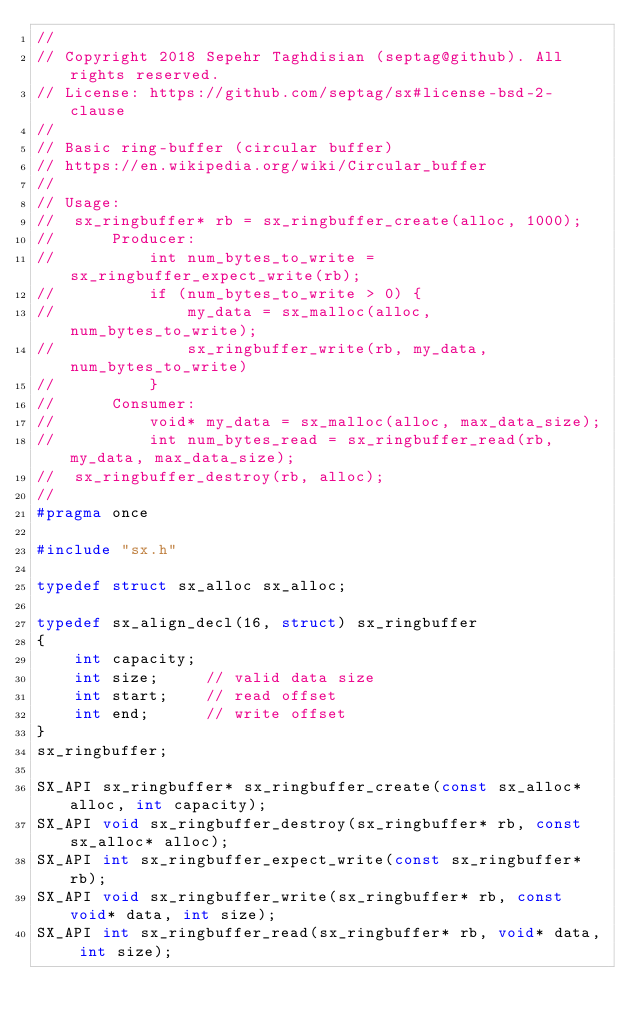Convert code to text. <code><loc_0><loc_0><loc_500><loc_500><_C_>//
// Copyright 2018 Sepehr Taghdisian (septag@github). All rights reserved.
// License: https://github.com/septag/sx#license-bsd-2-clause
//
// Basic ring-buffer (circular buffer)
// https://en.wikipedia.org/wiki/Circular_buffer
//
// Usage:
//  sx_ringbuffer* rb = sx_ringbuffer_create(alloc, 1000);
//      Producer:
//          int num_bytes_to_write = sx_ringbuffer_expect_write(rb);
//          if (num_bytes_to_write > 0) {
//              my_data = sx_malloc(alloc, num_bytes_to_write);
//              sx_ringbuffer_write(rb, my_data, num_bytes_to_write)
//          }
//      Consumer:
//          void* my_data = sx_malloc(alloc, max_data_size);
//          int num_bytes_read = sx_ringbuffer_read(rb, my_data, max_data_size);
//  sx_ringbuffer_destroy(rb, alloc);
//
#pragma once

#include "sx.h"

typedef struct sx_alloc sx_alloc;

typedef sx_align_decl(16, struct) sx_ringbuffer
{
    int capacity;
    int size;     // valid data size
    int start;    // read offset
    int end;      // write offset
}
sx_ringbuffer;

SX_API sx_ringbuffer* sx_ringbuffer_create(const sx_alloc* alloc, int capacity);
SX_API void sx_ringbuffer_destroy(sx_ringbuffer* rb, const sx_alloc* alloc);
SX_API int sx_ringbuffer_expect_write(const sx_ringbuffer* rb);
SX_API void sx_ringbuffer_write(sx_ringbuffer* rb, const void* data, int size);
SX_API int sx_ringbuffer_read(sx_ringbuffer* rb, void* data, int size);
</code> 